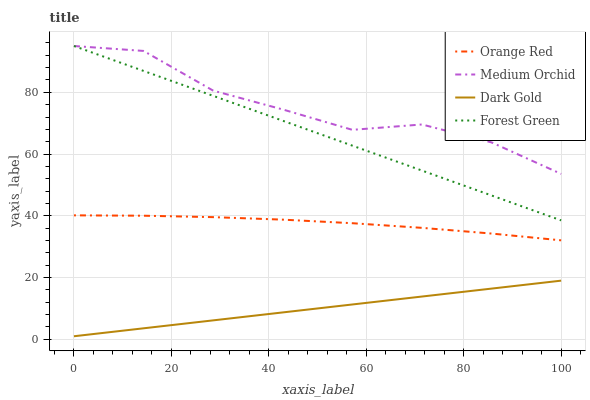Does Dark Gold have the minimum area under the curve?
Answer yes or no. Yes. Does Medium Orchid have the maximum area under the curve?
Answer yes or no. Yes. Does Orange Red have the minimum area under the curve?
Answer yes or no. No. Does Orange Red have the maximum area under the curve?
Answer yes or no. No. Is Dark Gold the smoothest?
Answer yes or no. Yes. Is Medium Orchid the roughest?
Answer yes or no. Yes. Is Orange Red the smoothest?
Answer yes or no. No. Is Orange Red the roughest?
Answer yes or no. No. Does Dark Gold have the lowest value?
Answer yes or no. Yes. Does Orange Red have the lowest value?
Answer yes or no. No. Does Medium Orchid have the highest value?
Answer yes or no. Yes. Does Orange Red have the highest value?
Answer yes or no. No. Is Orange Red less than Forest Green?
Answer yes or no. Yes. Is Forest Green greater than Dark Gold?
Answer yes or no. Yes. Does Medium Orchid intersect Forest Green?
Answer yes or no. Yes. Is Medium Orchid less than Forest Green?
Answer yes or no. No. Is Medium Orchid greater than Forest Green?
Answer yes or no. No. Does Orange Red intersect Forest Green?
Answer yes or no. No. 